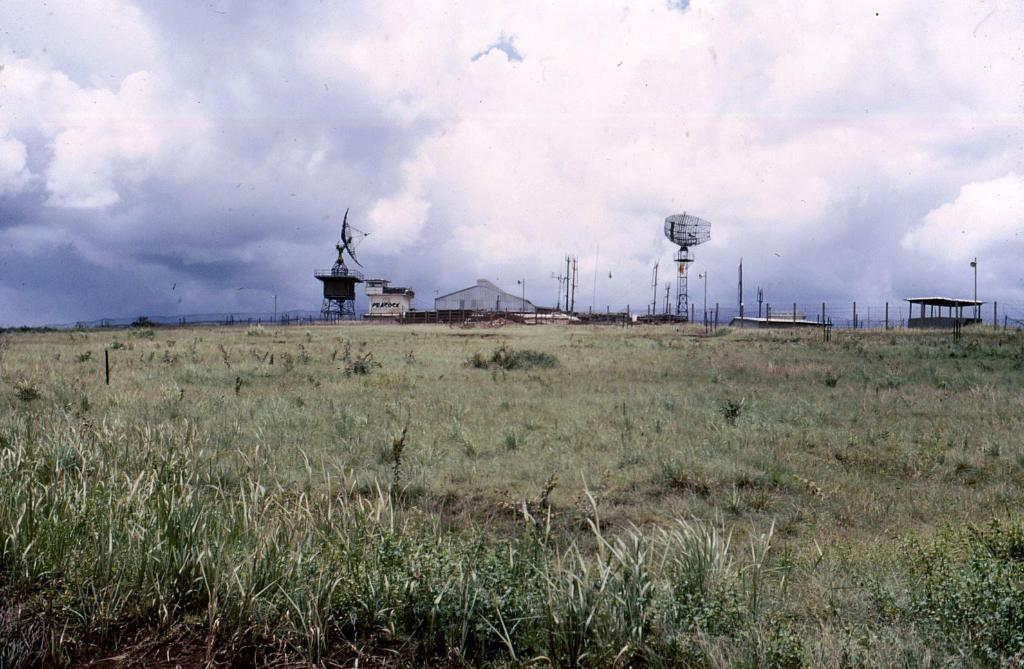What type of vegetation is visible in the image? There is grass in the image. What type of structures can be seen in the image? There are sheds, poles, and towers in the image. Can you tell me how many birds are sitting on the poles in the image? There are no birds present on the poles in the image. Is there a market visible in the image? There is no market visible in the image. 